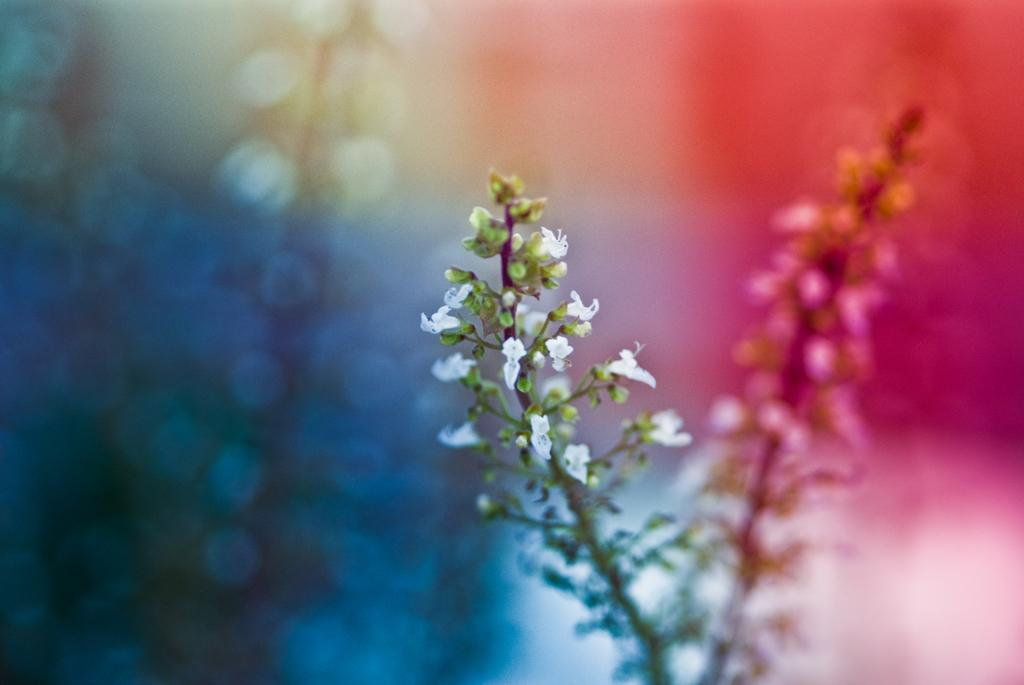What type of flowers can be seen on the plant in the image? There are white color flowers on a plant in the image. Can you describe the background of the image? The background of the image is colorful. How many oranges are hanging from the plant in the image? There are no oranges present in the image; it features white color flowers on a plant. What type of organization is responsible for the plant's growth in the image? There is no information about an organization responsible for the plant's growth in the image. 